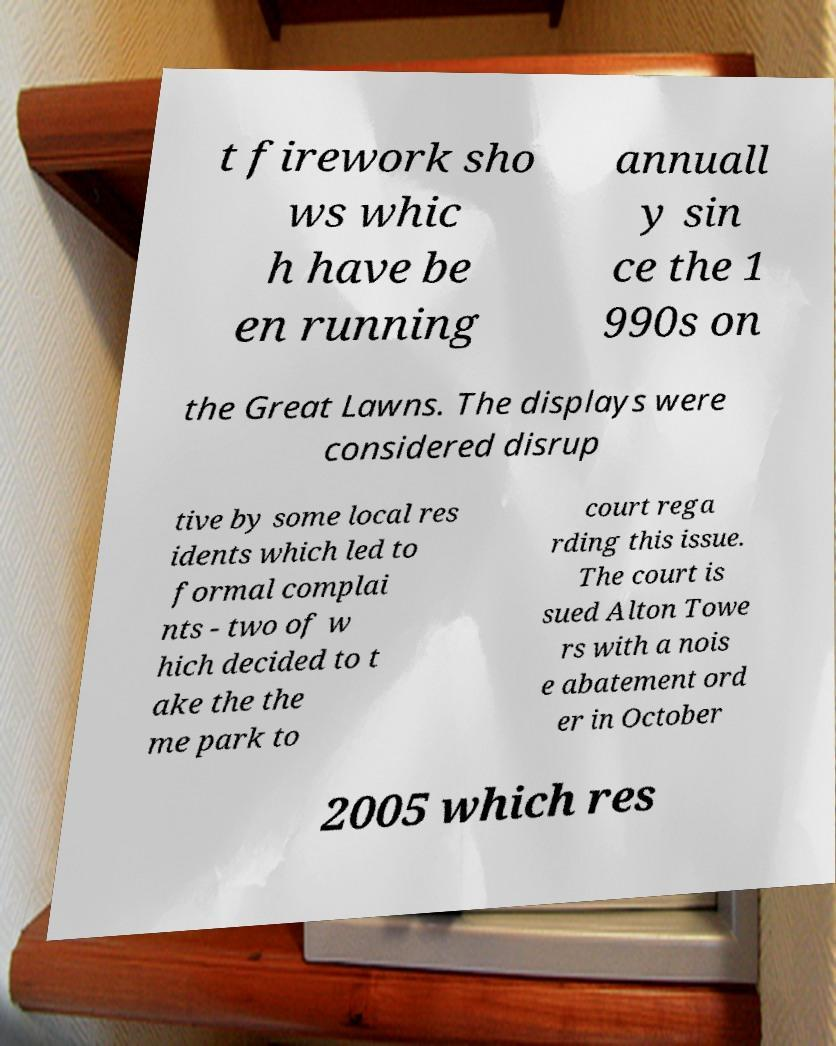Could you assist in decoding the text presented in this image and type it out clearly? t firework sho ws whic h have be en running annuall y sin ce the 1 990s on the Great Lawns. The displays were considered disrup tive by some local res idents which led to formal complai nts - two of w hich decided to t ake the the me park to court rega rding this issue. The court is sued Alton Towe rs with a nois e abatement ord er in October 2005 which res 